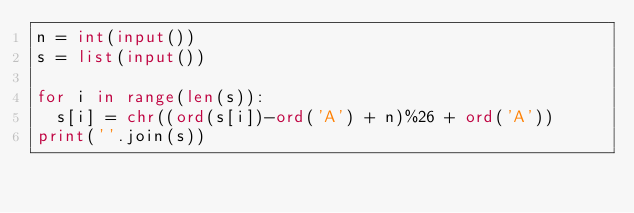Convert code to text. <code><loc_0><loc_0><loc_500><loc_500><_Python_>n = int(input())
s = list(input())

for i in range(len(s)):
	s[i] = chr((ord(s[i])-ord('A') + n)%26 + ord('A'))
print(''.join(s))</code> 